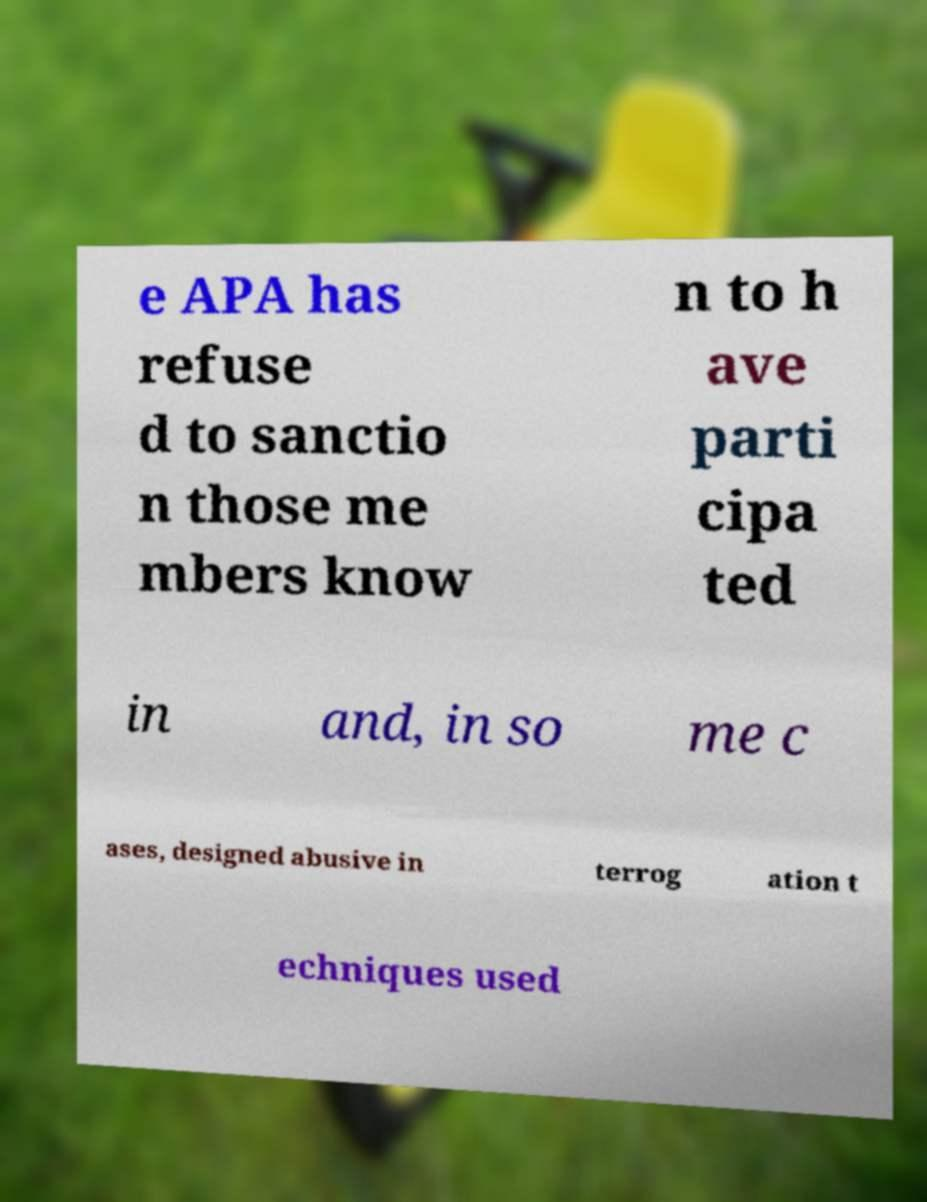I need the written content from this picture converted into text. Can you do that? e APA has refuse d to sanctio n those me mbers know n to h ave parti cipa ted in and, in so me c ases, designed abusive in terrog ation t echniques used 